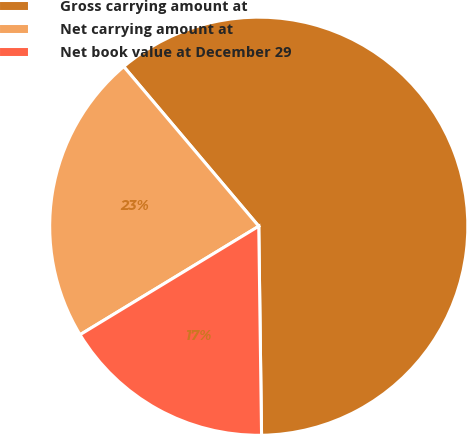<chart> <loc_0><loc_0><loc_500><loc_500><pie_chart><fcel>Gross carrying amount at<fcel>Net carrying amount at<fcel>Net book value at December 29<nl><fcel>60.96%<fcel>22.51%<fcel>16.53%<nl></chart> 